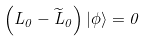Convert formula to latex. <formula><loc_0><loc_0><loc_500><loc_500>\left ( L _ { 0 } - \widetilde { L } _ { 0 } \right ) \left | \phi \right \rangle = 0</formula> 